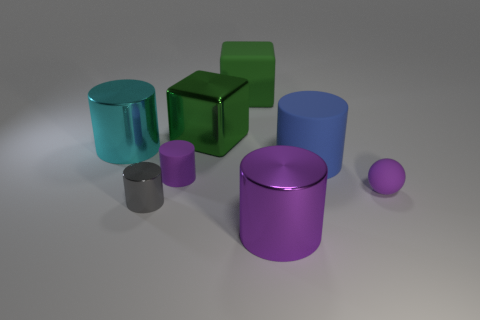Subtract 2 cylinders. How many cylinders are left? 3 Subtract all gray cylinders. How many cylinders are left? 4 Subtract all tiny matte cylinders. How many cylinders are left? 4 Add 2 purple rubber cylinders. How many objects exist? 10 Subtract all green cylinders. Subtract all blue blocks. How many cylinders are left? 5 Subtract all balls. How many objects are left? 7 Subtract all yellow cylinders. Subtract all big cyan metal objects. How many objects are left? 7 Add 3 tiny rubber cylinders. How many tiny rubber cylinders are left? 4 Add 8 purple metallic spheres. How many purple metallic spheres exist? 8 Subtract 1 purple balls. How many objects are left? 7 